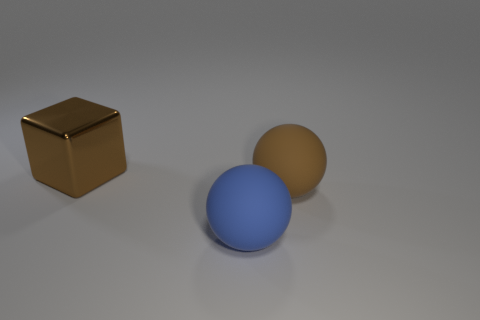There is a big brown object that is in front of the brown block; is it the same shape as the big blue thing?
Provide a succinct answer. Yes. How many objects are large brown balls or large objects right of the brown block?
Keep it short and to the point. 2. Is the number of tiny green metal balls less than the number of rubber objects?
Keep it short and to the point. Yes. Is the number of big cubes greater than the number of green rubber cylinders?
Offer a very short reply. Yes. How many other objects are there of the same material as the large block?
Your answer should be compact. 0. There is a large matte object in front of the brown thing that is in front of the large brown block; what number of brown blocks are behind it?
Give a very brief answer. 1. What number of matte objects are large blue things or brown balls?
Make the answer very short. 2. What is the size of the rubber ball to the right of the rubber sphere in front of the large brown sphere?
Your answer should be compact. Large. There is a large rubber thing behind the large blue thing; is it the same color as the rubber ball in front of the brown matte thing?
Keep it short and to the point. No. There is a large thing that is both on the left side of the large brown rubber object and in front of the metal block; what is its color?
Your answer should be compact. Blue. 